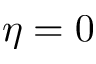<formula> <loc_0><loc_0><loc_500><loc_500>\eta = 0</formula> 